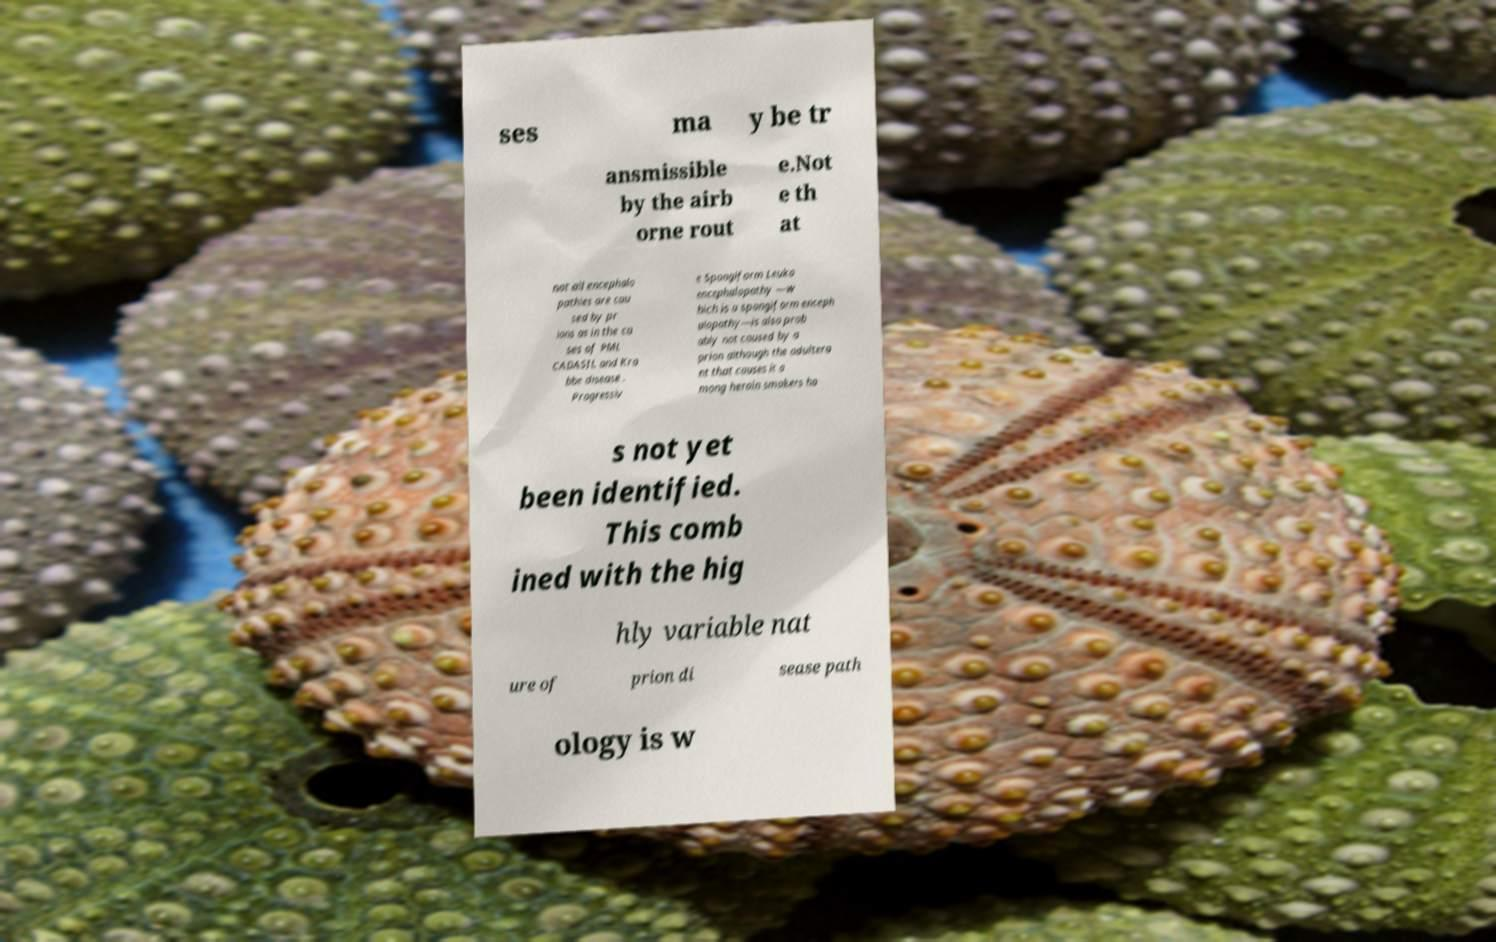What messages or text are displayed in this image? I need them in a readable, typed format. ses ma y be tr ansmissible by the airb orne rout e.Not e th at not all encephalo pathies are cau sed by pr ions as in the ca ses of PML CADASIL and Kra bbe disease . Progressiv e Spongiform Leuko encephalopathy —w hich is a spongiform enceph alopathy—is also prob ably not caused by a prion although the adultera nt that causes it a mong heroin smokers ha s not yet been identified. This comb ined with the hig hly variable nat ure of prion di sease path ology is w 